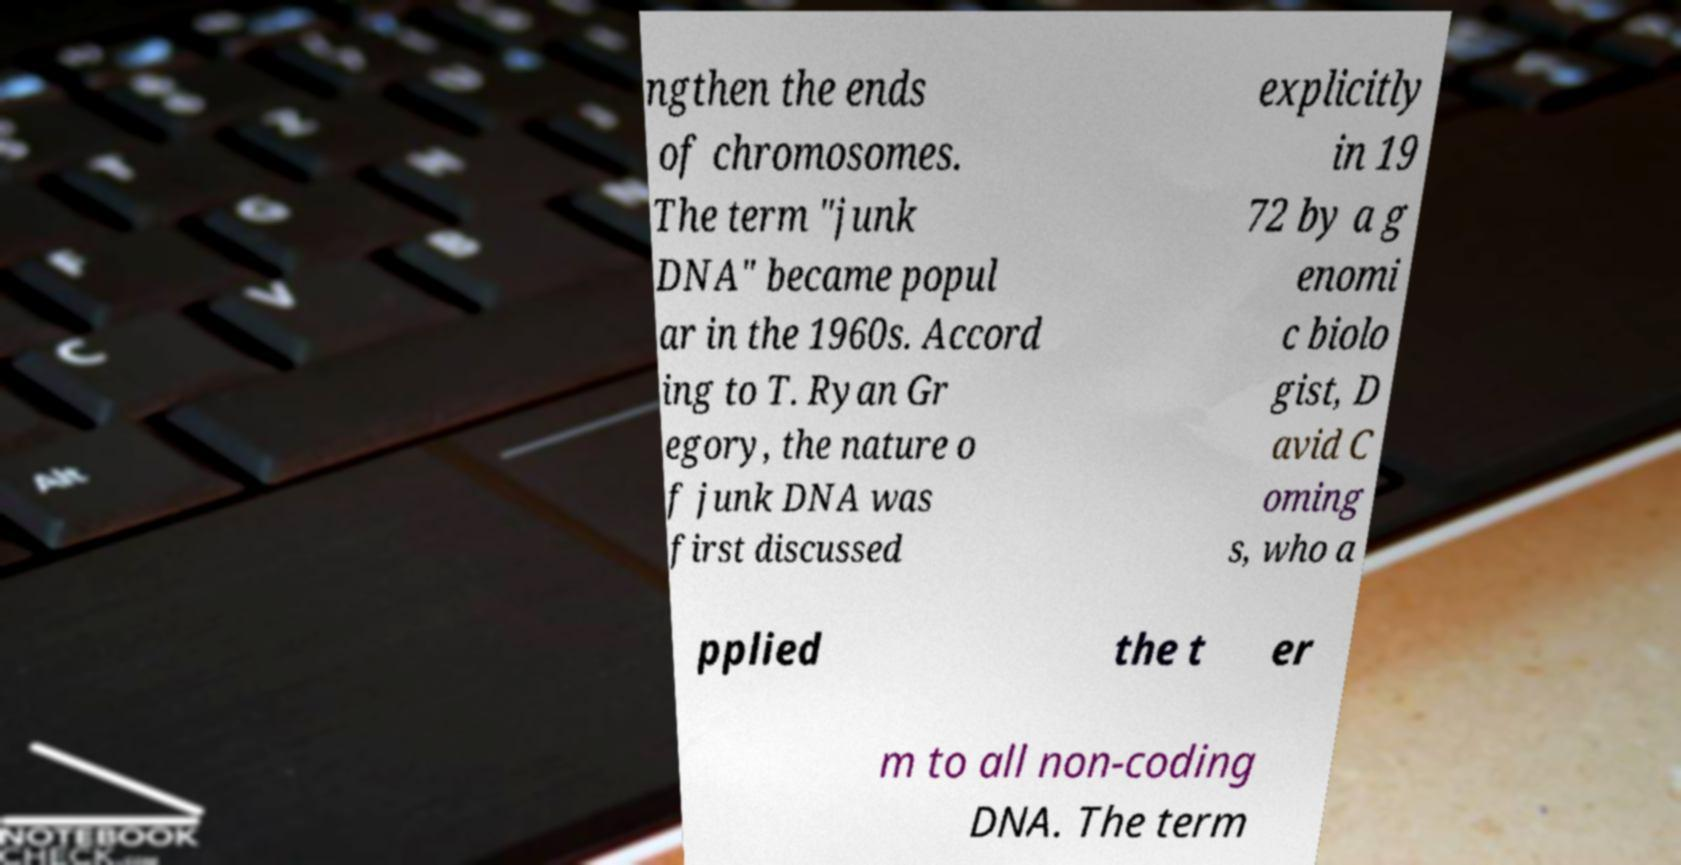For documentation purposes, I need the text within this image transcribed. Could you provide that? ngthen the ends of chromosomes. The term "junk DNA" became popul ar in the 1960s. Accord ing to T. Ryan Gr egory, the nature o f junk DNA was first discussed explicitly in 19 72 by a g enomi c biolo gist, D avid C oming s, who a pplied the t er m to all non-coding DNA. The term 